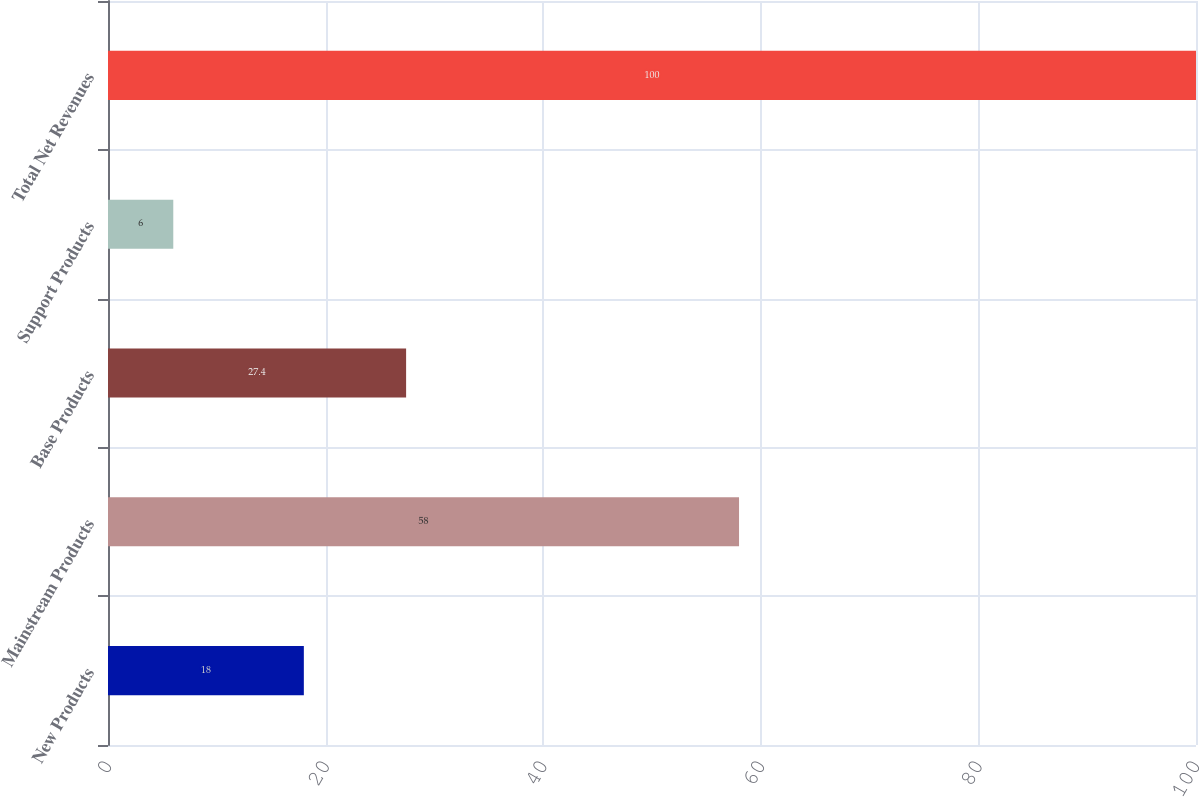Convert chart to OTSL. <chart><loc_0><loc_0><loc_500><loc_500><bar_chart><fcel>New Products<fcel>Mainstream Products<fcel>Base Products<fcel>Support Products<fcel>Total Net Revenues<nl><fcel>18<fcel>58<fcel>27.4<fcel>6<fcel>100<nl></chart> 